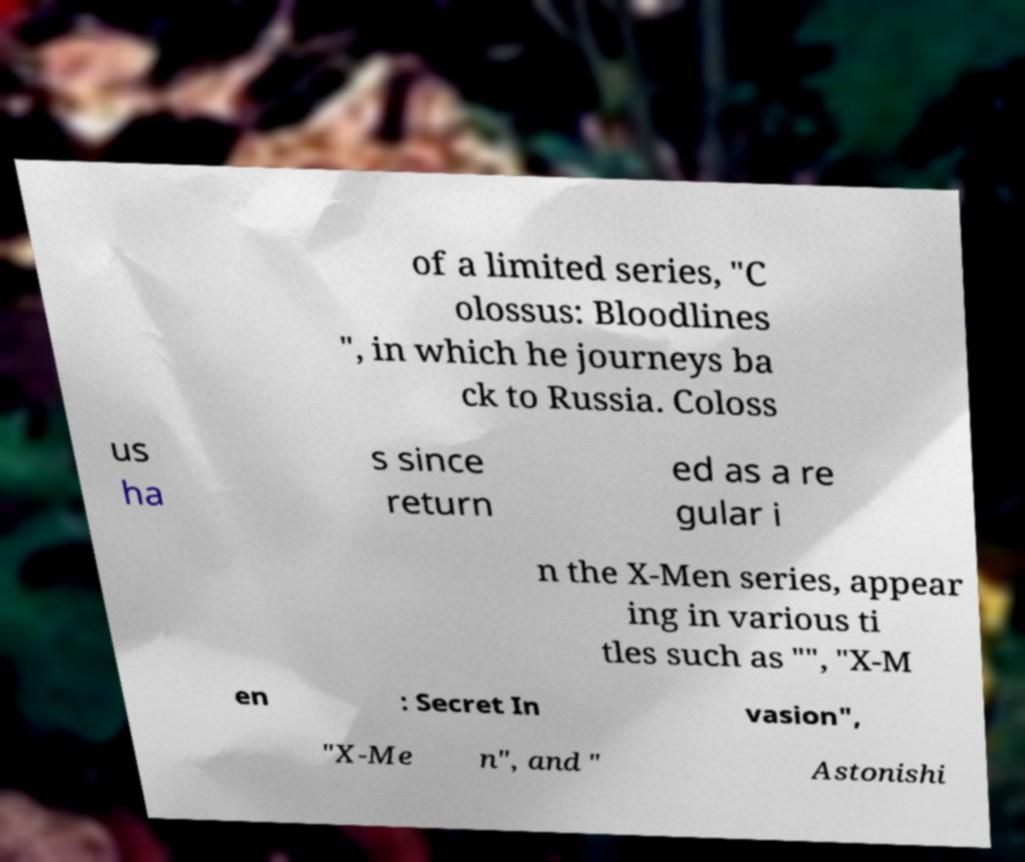Could you extract and type out the text from this image? of a limited series, "C olossus: Bloodlines ", in which he journeys ba ck to Russia. Coloss us ha s since return ed as a re gular i n the X-Men series, appear ing in various ti tles such as "", "X-M en : Secret In vasion", "X-Me n", and " Astonishi 